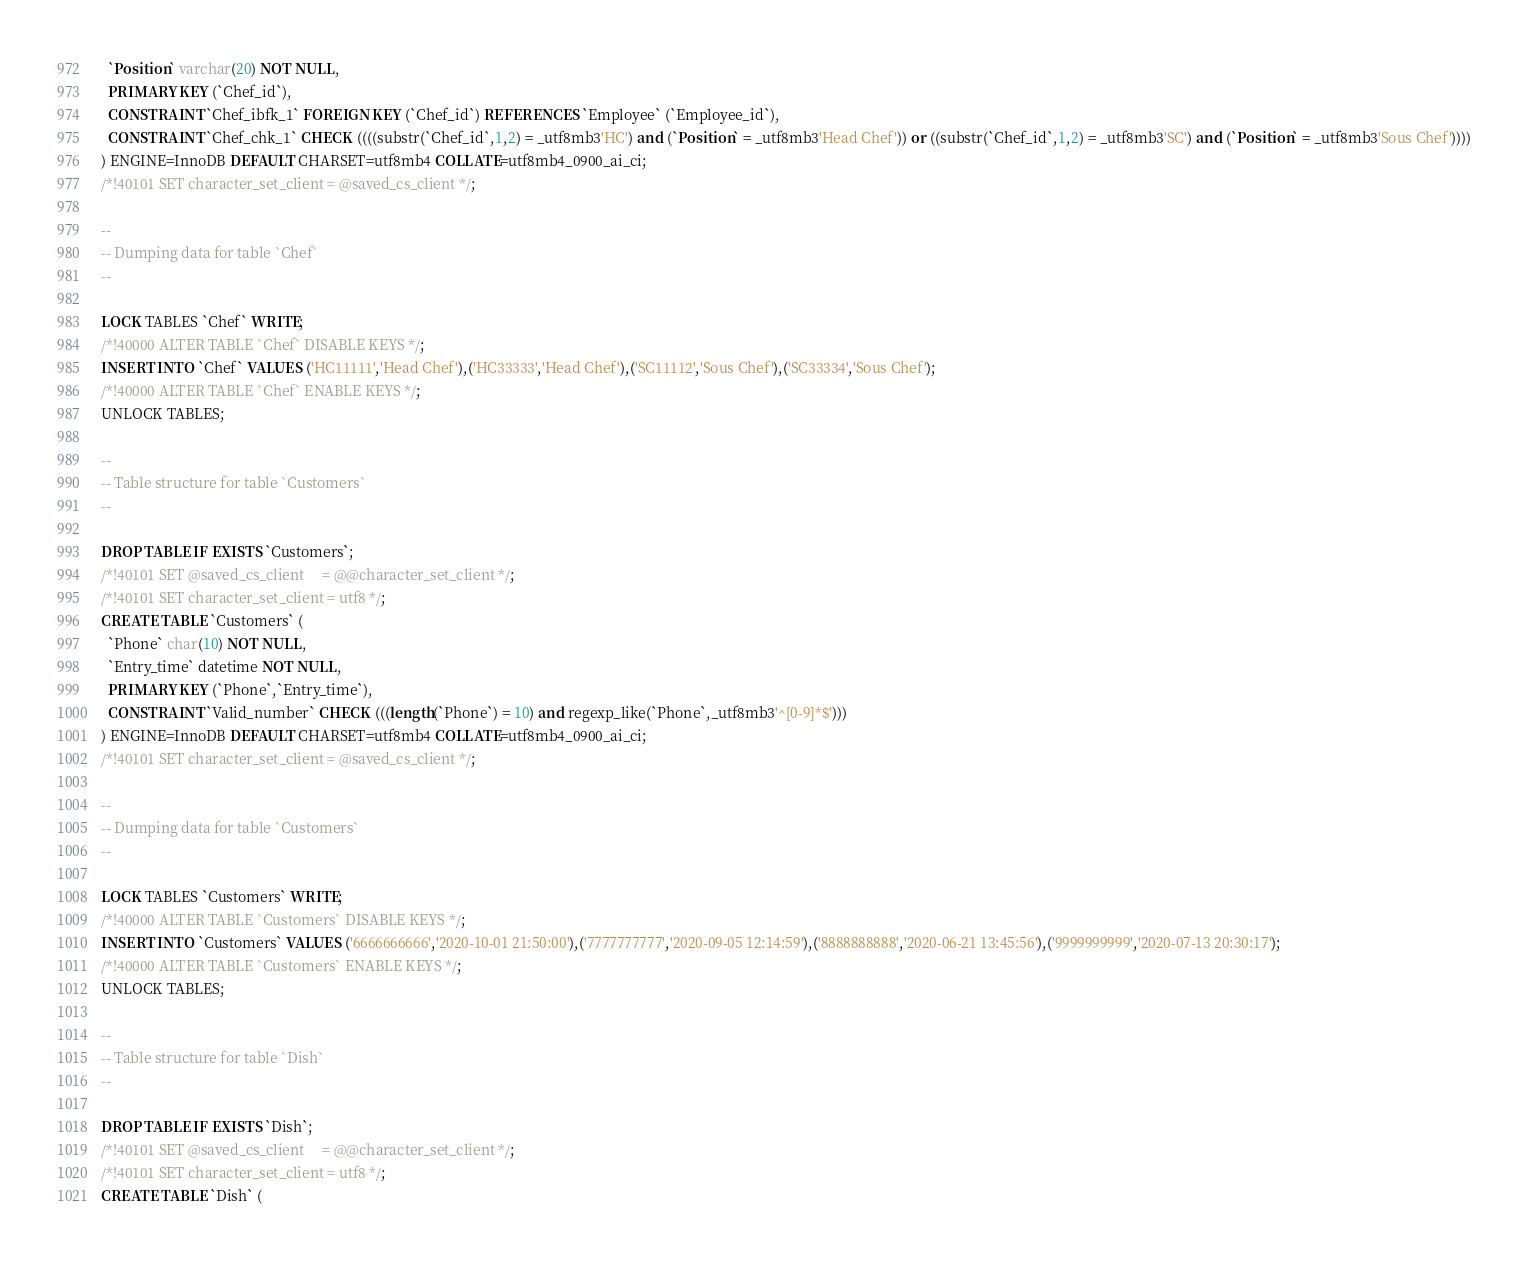<code> <loc_0><loc_0><loc_500><loc_500><_SQL_>  `Position` varchar(20) NOT NULL,
  PRIMARY KEY (`Chef_id`),
  CONSTRAINT `Chef_ibfk_1` FOREIGN KEY (`Chef_id`) REFERENCES `Employee` (`Employee_id`),
  CONSTRAINT `Chef_chk_1` CHECK ((((substr(`Chef_id`,1,2) = _utf8mb3'HC') and (`Position` = _utf8mb3'Head Chef')) or ((substr(`Chef_id`,1,2) = _utf8mb3'SC') and (`Position` = _utf8mb3'Sous Chef'))))
) ENGINE=InnoDB DEFAULT CHARSET=utf8mb4 COLLATE=utf8mb4_0900_ai_ci;
/*!40101 SET character_set_client = @saved_cs_client */;

--
-- Dumping data for table `Chef`
--

LOCK TABLES `Chef` WRITE;
/*!40000 ALTER TABLE `Chef` DISABLE KEYS */;
INSERT INTO `Chef` VALUES ('HC11111','Head Chef'),('HC33333','Head Chef'),('SC11112','Sous Chef'),('SC33334','Sous Chef');
/*!40000 ALTER TABLE `Chef` ENABLE KEYS */;
UNLOCK TABLES;

--
-- Table structure for table `Customers`
--

DROP TABLE IF EXISTS `Customers`;
/*!40101 SET @saved_cs_client     = @@character_set_client */;
/*!40101 SET character_set_client = utf8 */;
CREATE TABLE `Customers` (
  `Phone` char(10) NOT NULL,
  `Entry_time` datetime NOT NULL,
  PRIMARY KEY (`Phone`,`Entry_time`),
  CONSTRAINT `Valid_number` CHECK (((length(`Phone`) = 10) and regexp_like(`Phone`,_utf8mb3'^[0-9]*$')))
) ENGINE=InnoDB DEFAULT CHARSET=utf8mb4 COLLATE=utf8mb4_0900_ai_ci;
/*!40101 SET character_set_client = @saved_cs_client */;

--
-- Dumping data for table `Customers`
--

LOCK TABLES `Customers` WRITE;
/*!40000 ALTER TABLE `Customers` DISABLE KEYS */;
INSERT INTO `Customers` VALUES ('6666666666','2020-10-01 21:50:00'),('7777777777','2020-09-05 12:14:59'),('8888888888','2020-06-21 13:45:56'),('9999999999','2020-07-13 20:30:17');
/*!40000 ALTER TABLE `Customers` ENABLE KEYS */;
UNLOCK TABLES;

--
-- Table structure for table `Dish`
--

DROP TABLE IF EXISTS `Dish`;
/*!40101 SET @saved_cs_client     = @@character_set_client */;
/*!40101 SET character_set_client = utf8 */;
CREATE TABLE `Dish` (</code> 